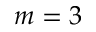Convert formula to latex. <formula><loc_0><loc_0><loc_500><loc_500>m = 3</formula> 